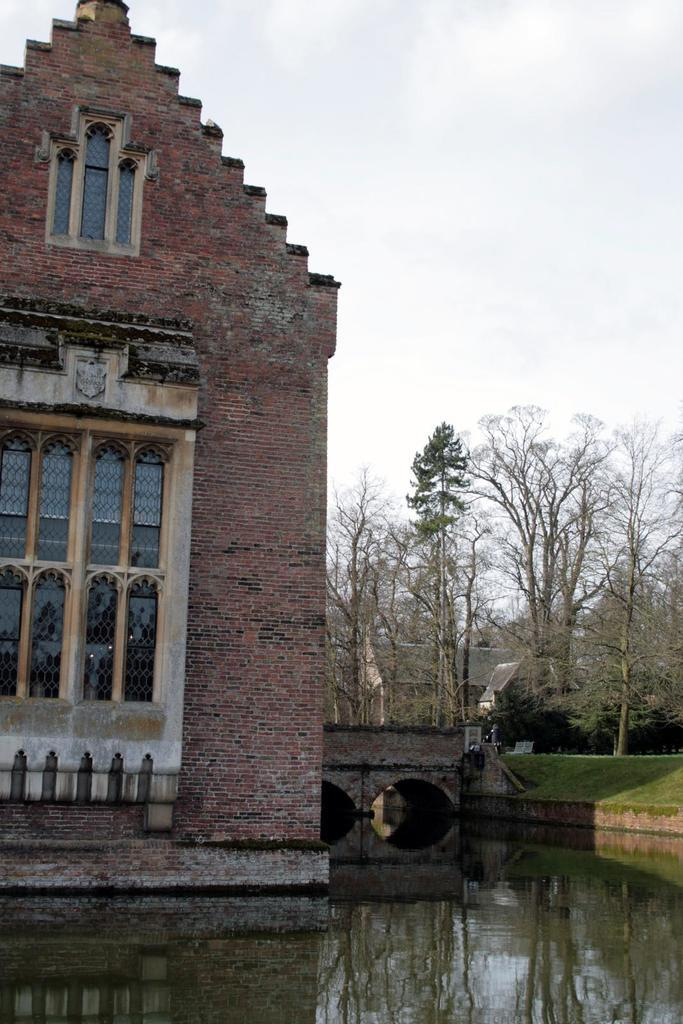What type of structure is present in the image? There is a building in the image. What natural feature can be seen in the image? There is a lake in the image. What type of vegetation is present in the image? There are many trees in the image. Where is the mailbox located in the image? There is no mailbox present in the image. What process is being carried out in the image? The image does not depict any specific process; it shows a building, a lake, and trees. 